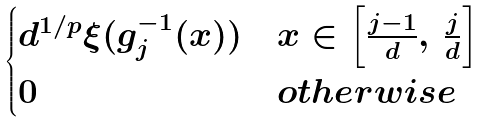<formula> <loc_0><loc_0><loc_500><loc_500>\begin{cases} d ^ { 1 / p } \xi ( g _ { j } ^ { - 1 } ( x ) ) & x \in \left [ \frac { j - 1 } { d } , \, \frac { j } { d } \right ] \\ 0 & { o t h e r w i s e } \end{cases}</formula> 